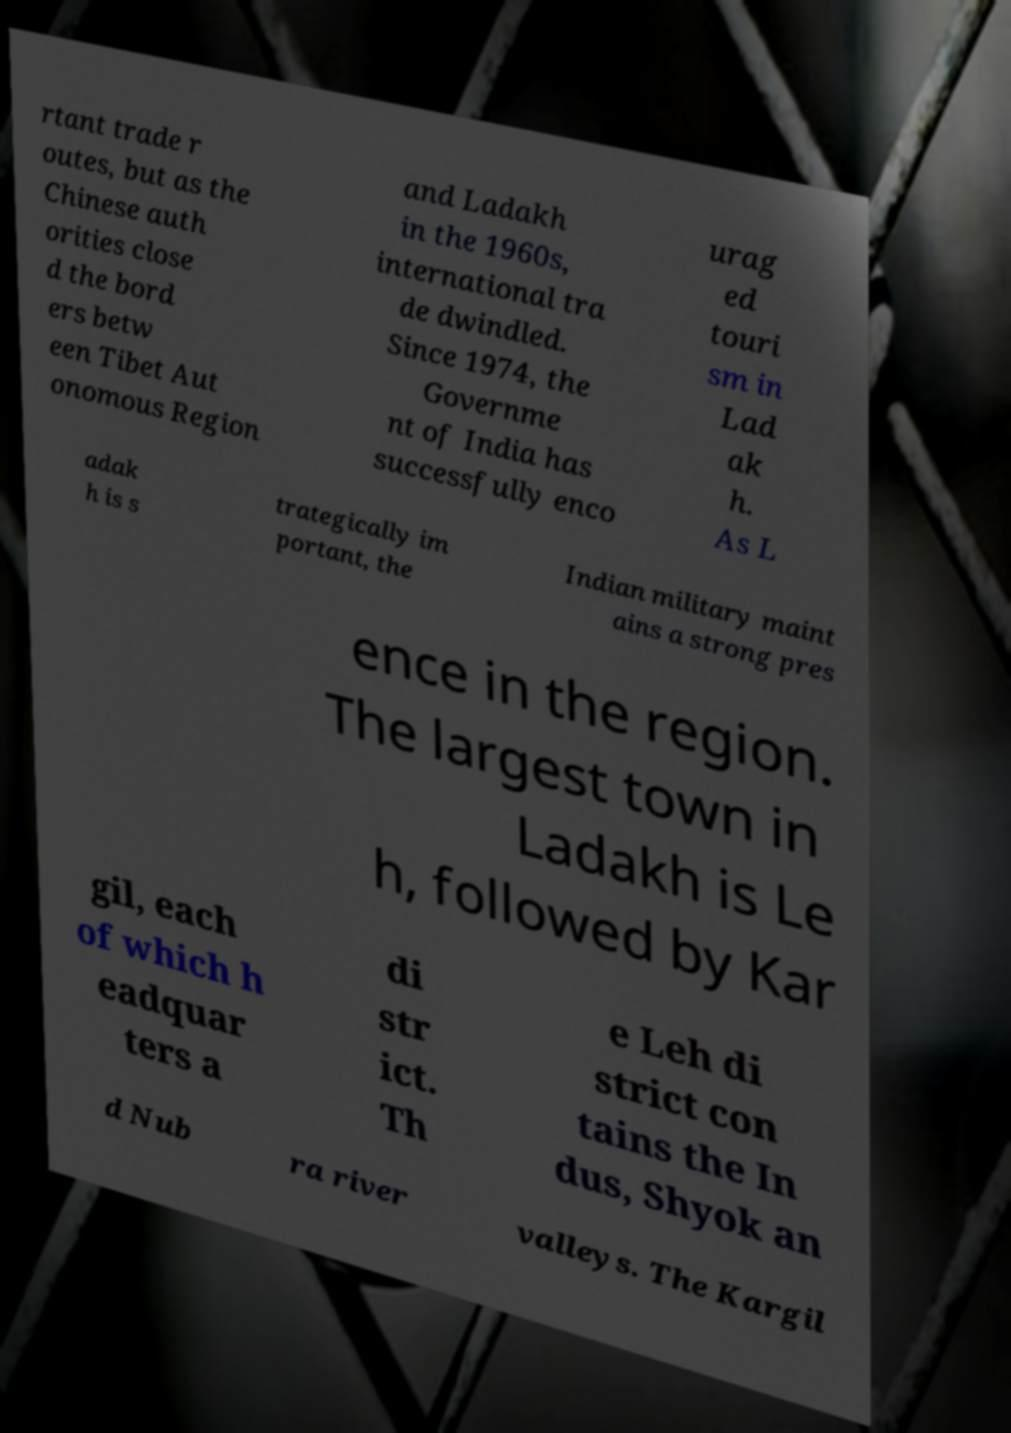Could you assist in decoding the text presented in this image and type it out clearly? rtant trade r outes, but as the Chinese auth orities close d the bord ers betw een Tibet Aut onomous Region and Ladakh in the 1960s, international tra de dwindled. Since 1974, the Governme nt of India has successfully enco urag ed touri sm in Lad ak h. As L adak h is s trategically im portant, the Indian military maint ains a strong pres ence in the region. The largest town in Ladakh is Le h, followed by Kar gil, each of which h eadquar ters a di str ict. Th e Leh di strict con tains the In dus, Shyok an d Nub ra river valleys. The Kargil 